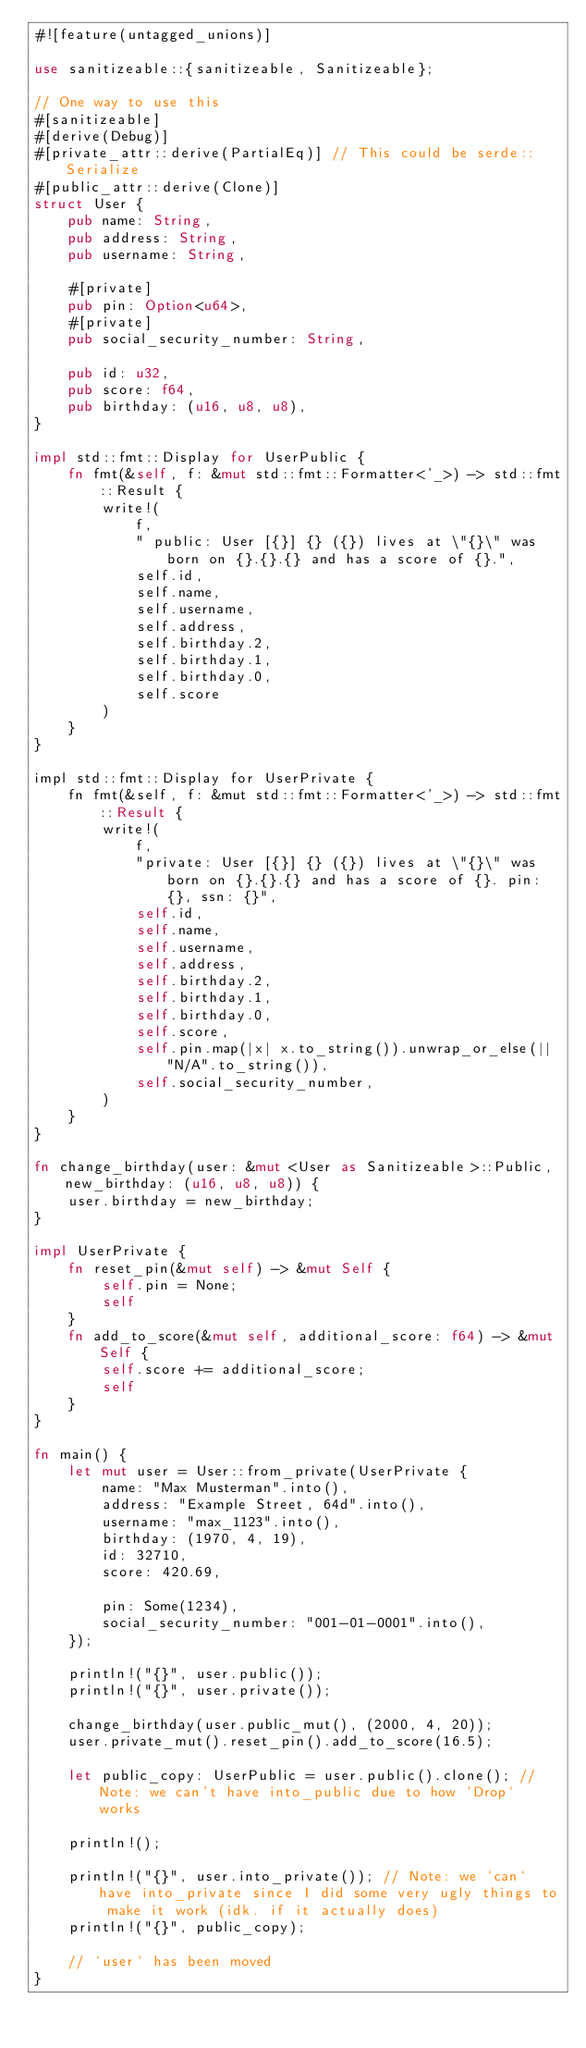Convert code to text. <code><loc_0><loc_0><loc_500><loc_500><_Rust_>#![feature(untagged_unions)]

use sanitizeable::{sanitizeable, Sanitizeable};

// One way to use this
#[sanitizeable]
#[derive(Debug)]
#[private_attr::derive(PartialEq)] // This could be serde::Serialize
#[public_attr::derive(Clone)]
struct User {
    pub name: String,
    pub address: String,
    pub username: String,

    #[private]
    pub pin: Option<u64>,
    #[private]
    pub social_security_number: String,

    pub id: u32,
    pub score: f64,
    pub birthday: (u16, u8, u8),
}

impl std::fmt::Display for UserPublic {
    fn fmt(&self, f: &mut std::fmt::Formatter<'_>) -> std::fmt::Result {
        write!(
            f,
            " public: User [{}] {} ({}) lives at \"{}\" was born on {}.{}.{} and has a score of {}.",
            self.id,
            self.name,
            self.username,
            self.address,
            self.birthday.2,
            self.birthday.1,
            self.birthday.0,
            self.score
        )
    }
}

impl std::fmt::Display for UserPrivate {
    fn fmt(&self, f: &mut std::fmt::Formatter<'_>) -> std::fmt::Result {
        write!(
            f,
            "private: User [{}] {} ({}) lives at \"{}\" was born on {}.{}.{} and has a score of {}. pin: {}, ssn: {}",
            self.id,
            self.name,
            self.username,
            self.address,
            self.birthday.2,
            self.birthday.1,
            self.birthday.0,
            self.score,
            self.pin.map(|x| x.to_string()).unwrap_or_else(|| "N/A".to_string()),
            self.social_security_number,
        )
    }
}

fn change_birthday(user: &mut <User as Sanitizeable>::Public, new_birthday: (u16, u8, u8)) {
    user.birthday = new_birthday;
}

impl UserPrivate {
    fn reset_pin(&mut self) -> &mut Self {
        self.pin = None;
        self
    }
    fn add_to_score(&mut self, additional_score: f64) -> &mut Self {
        self.score += additional_score;
        self
    }
}

fn main() {
    let mut user = User::from_private(UserPrivate {
        name: "Max Musterman".into(),
        address: "Example Street, 64d".into(),
        username: "max_1123".into(),
        birthday: (1970, 4, 19),
        id: 32710,
        score: 420.69,

        pin: Some(1234),
        social_security_number: "001-01-0001".into(),
    });

    println!("{}", user.public());
    println!("{}", user.private());

    change_birthday(user.public_mut(), (2000, 4, 20));
    user.private_mut().reset_pin().add_to_score(16.5);

    let public_copy: UserPublic = user.public().clone(); // Note: we can't have into_public due to how `Drop` works

    println!();

    println!("{}", user.into_private()); // Note: we `can` have into_private since I did some very ugly things to make it work (idk. if it actually does)
    println!("{}", public_copy);

    // `user` has been moved
}
</code> 